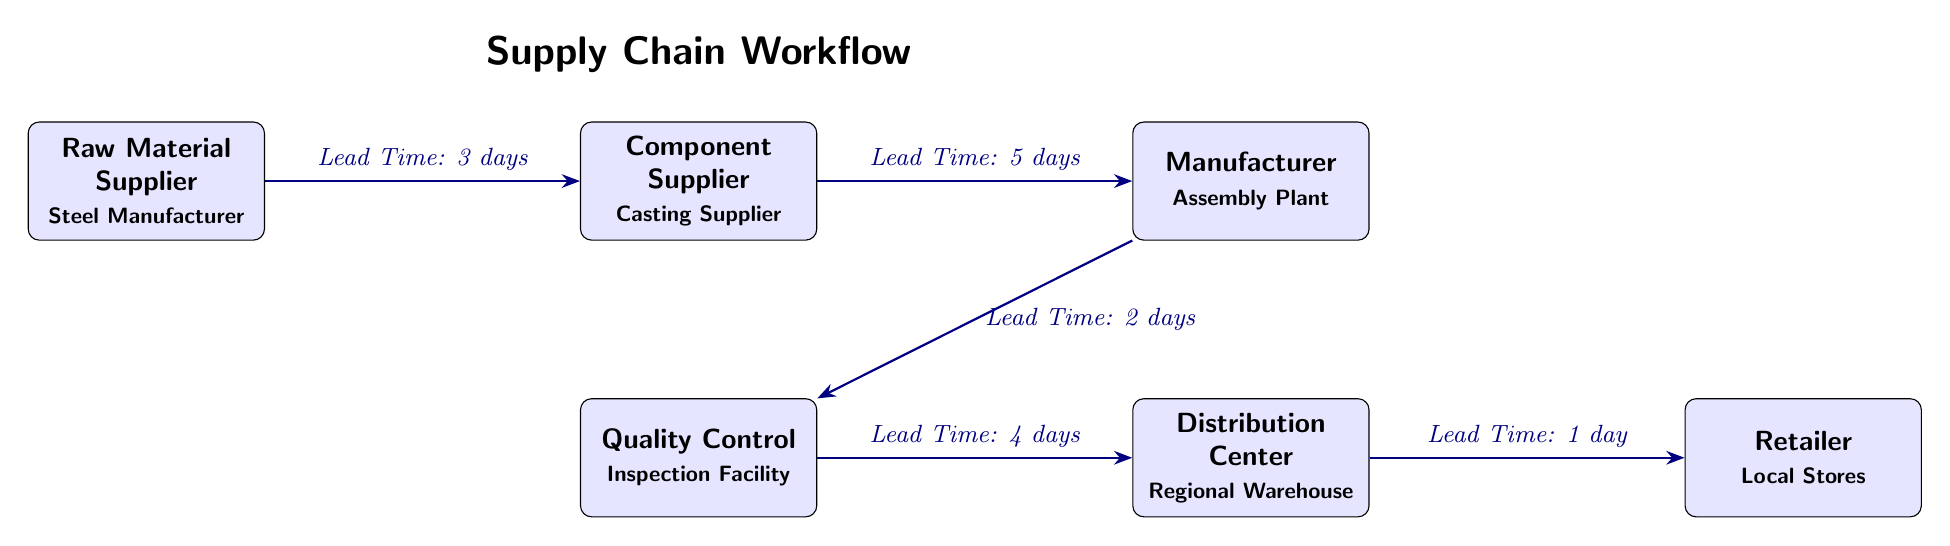What is the lead time from the Raw Material Supplier to the Component Supplier? The diagram indicates that the arrow leading from the Raw Material Supplier to the Component Supplier has a label that states "Lead Time: 3 days". Thus, the direct lead time between these two nodes is 3 days.
Answer: 3 days How many nodes are present in the supply chain workflow? The diagram displays a total of six distinct nodes (Raw Material Supplier, Component Supplier, Manufacturer, Quality Control, Distribution Center, Retailer). Counting these nodes gives us a total count of six.
Answer: 6 What is the lead time from the Manufacturer to the Quality Control facility? Looking at the diagram, there is an arrow from the Manufacturer to the Quality Control facility that reads "Lead Time: 2 days". Therefore, this is the specified lead time for that connection.
Answer: 2 days Which node follows the Distribution Center in the workflow? By examining the diagram, the arrow leading out of the Distribution Center points to the Retailer. Thus, the immediate next node after the Distribution Center is the Retailer.
Answer: Retailer What is the total lead time from the Raw Material Supplier to the Retailer? To find the total lead time, we need to sum the lead times of each segment in the workflow: 3 days (Raw Material to Component) + 5 days (Component to Manufacturer) + 2 days (Manufacturer to Quality Control) + 4 days (Quality Control to Distribution Center) + 1 day (Distribution Center to Retailer). Calculating gives a total of 15 days.
Answer: 15 days 